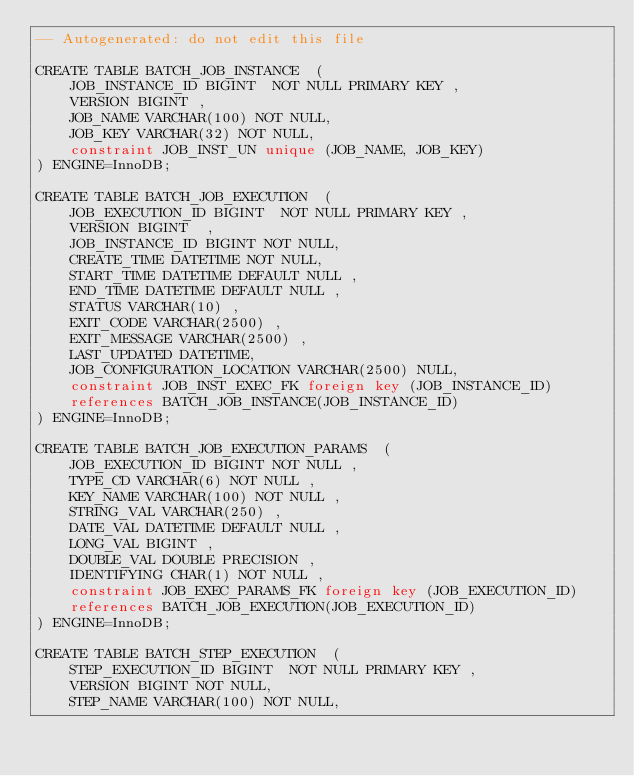<code> <loc_0><loc_0><loc_500><loc_500><_SQL_>-- Autogenerated: do not edit this file

CREATE TABLE BATCH_JOB_INSTANCE  (
	JOB_INSTANCE_ID BIGINT  NOT NULL PRIMARY KEY ,
	VERSION BIGINT ,
	JOB_NAME VARCHAR(100) NOT NULL,
	JOB_KEY VARCHAR(32) NOT NULL,
	constraint JOB_INST_UN unique (JOB_NAME, JOB_KEY)
) ENGINE=InnoDB;

CREATE TABLE BATCH_JOB_EXECUTION  (
	JOB_EXECUTION_ID BIGINT  NOT NULL PRIMARY KEY ,
	VERSION BIGINT  ,
	JOB_INSTANCE_ID BIGINT NOT NULL,
	CREATE_TIME DATETIME NOT NULL,
	START_TIME DATETIME DEFAULT NULL ,
	END_TIME DATETIME DEFAULT NULL ,
	STATUS VARCHAR(10) ,
	EXIT_CODE VARCHAR(2500) ,
	EXIT_MESSAGE VARCHAR(2500) ,
	LAST_UPDATED DATETIME,
	JOB_CONFIGURATION_LOCATION VARCHAR(2500) NULL,
	constraint JOB_INST_EXEC_FK foreign key (JOB_INSTANCE_ID)
	references BATCH_JOB_INSTANCE(JOB_INSTANCE_ID)
) ENGINE=InnoDB;

CREATE TABLE BATCH_JOB_EXECUTION_PARAMS  (
	JOB_EXECUTION_ID BIGINT NOT NULL ,
	TYPE_CD VARCHAR(6) NOT NULL ,
	KEY_NAME VARCHAR(100) NOT NULL ,
	STRING_VAL VARCHAR(250) ,
	DATE_VAL DATETIME DEFAULT NULL ,
	LONG_VAL BIGINT ,
	DOUBLE_VAL DOUBLE PRECISION ,
	IDENTIFYING CHAR(1) NOT NULL ,
	constraint JOB_EXEC_PARAMS_FK foreign key (JOB_EXECUTION_ID)
	references BATCH_JOB_EXECUTION(JOB_EXECUTION_ID)
) ENGINE=InnoDB;

CREATE TABLE BATCH_STEP_EXECUTION  (
	STEP_EXECUTION_ID BIGINT  NOT NULL PRIMARY KEY ,
	VERSION BIGINT NOT NULL,
	STEP_NAME VARCHAR(100) NOT NULL,</code> 